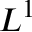Convert formula to latex. <formula><loc_0><loc_0><loc_500><loc_500>L ^ { 1 }</formula> 